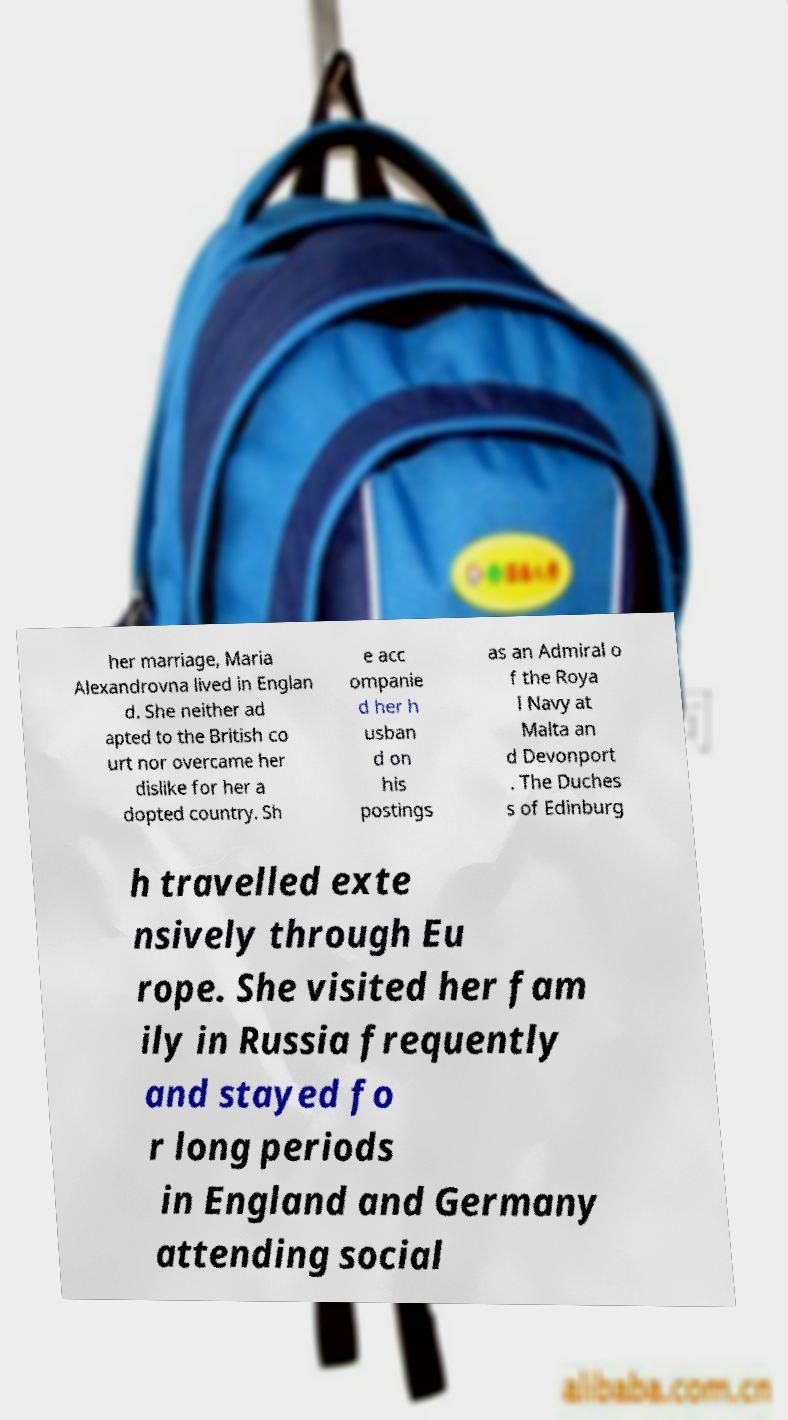Please read and relay the text visible in this image. What does it say? her marriage, Maria Alexandrovna lived in Englan d. She neither ad apted to the British co urt nor overcame her dislike for her a dopted country. Sh e acc ompanie d her h usban d on his postings as an Admiral o f the Roya l Navy at Malta an d Devonport . The Duches s of Edinburg h travelled exte nsively through Eu rope. She visited her fam ily in Russia frequently and stayed fo r long periods in England and Germany attending social 